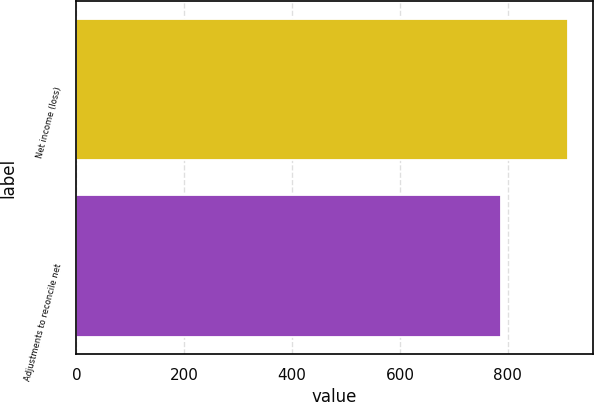<chart> <loc_0><loc_0><loc_500><loc_500><bar_chart><fcel>Net income (loss)<fcel>Adjustments to reconcile net<nl><fcel>912<fcel>787<nl></chart> 